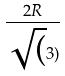Convert formula to latex. <formula><loc_0><loc_0><loc_500><loc_500>\frac { 2 R } { \sqrt { ( } 3 ) }</formula> 